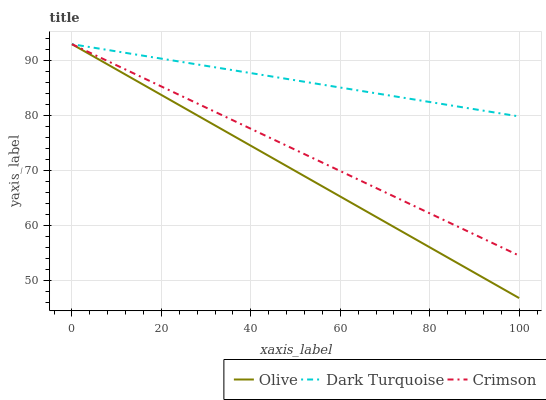Does Olive have the minimum area under the curve?
Answer yes or no. Yes. Does Dark Turquoise have the maximum area under the curve?
Answer yes or no. Yes. Does Crimson have the minimum area under the curve?
Answer yes or no. No. Does Crimson have the maximum area under the curve?
Answer yes or no. No. Is Dark Turquoise the smoothest?
Answer yes or no. Yes. Is Crimson the roughest?
Answer yes or no. Yes. Is Crimson the smoothest?
Answer yes or no. No. Is Dark Turquoise the roughest?
Answer yes or no. No. Does Olive have the lowest value?
Answer yes or no. Yes. Does Crimson have the lowest value?
Answer yes or no. No. Does Crimson have the highest value?
Answer yes or no. Yes. Does Crimson intersect Olive?
Answer yes or no. Yes. Is Crimson less than Olive?
Answer yes or no. No. Is Crimson greater than Olive?
Answer yes or no. No. 